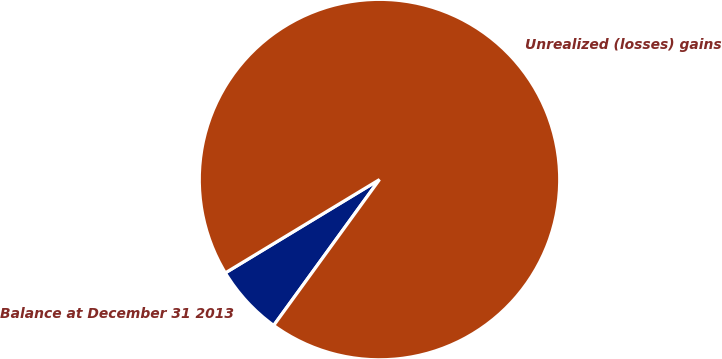Convert chart to OTSL. <chart><loc_0><loc_0><loc_500><loc_500><pie_chart><fcel>Balance at December 31 2013<fcel>Unrealized (losses) gains<nl><fcel>6.35%<fcel>93.65%<nl></chart> 